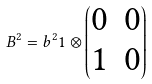Convert formula to latex. <formula><loc_0><loc_0><loc_500><loc_500>B ^ { 2 } = b ^ { 2 } { 1 } \otimes \begin{pmatrix} 0 & 0 \\ 1 & 0 \end{pmatrix}</formula> 